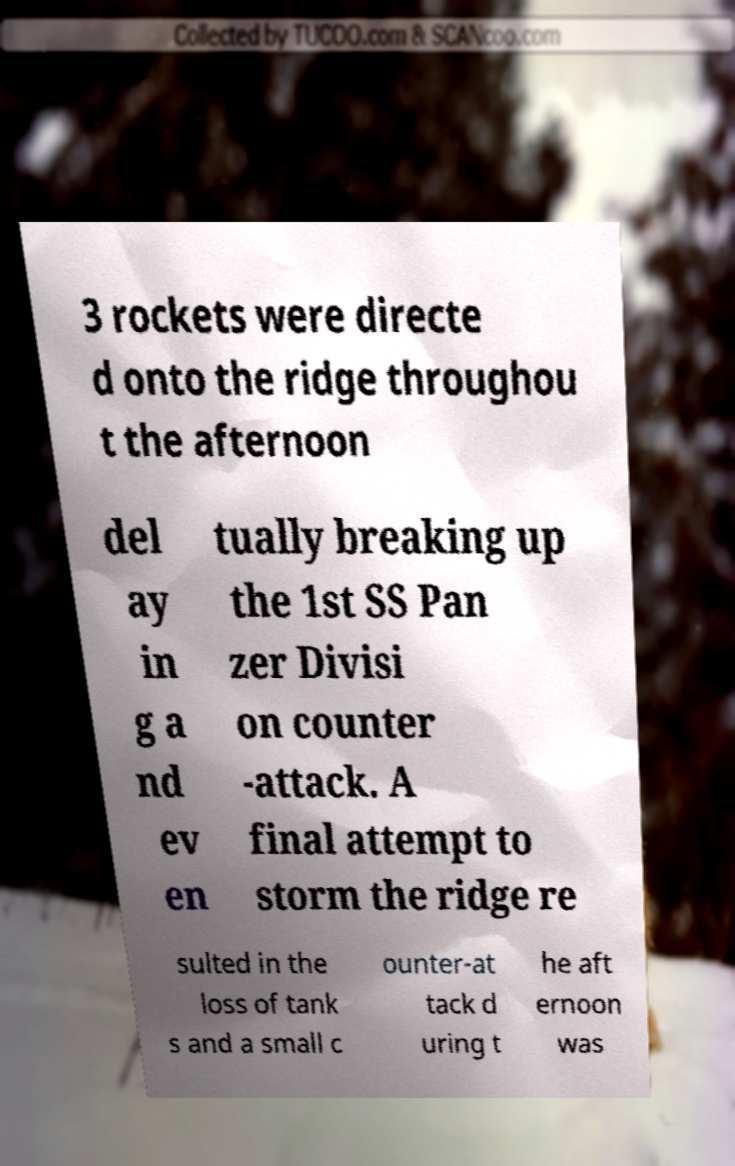For documentation purposes, I need the text within this image transcribed. Could you provide that? 3 rockets were directe d onto the ridge throughou t the afternoon del ay in g a nd ev en tually breaking up the 1st SS Pan zer Divisi on counter -attack. A final attempt to storm the ridge re sulted in the loss of tank s and a small c ounter-at tack d uring t he aft ernoon was 